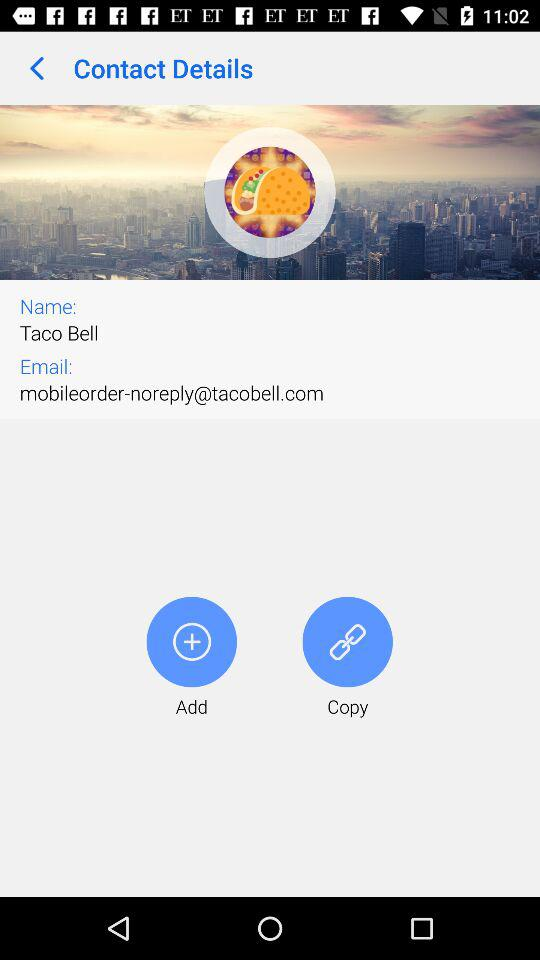How many contact details are shown?
Answer the question using a single word or phrase. 2 